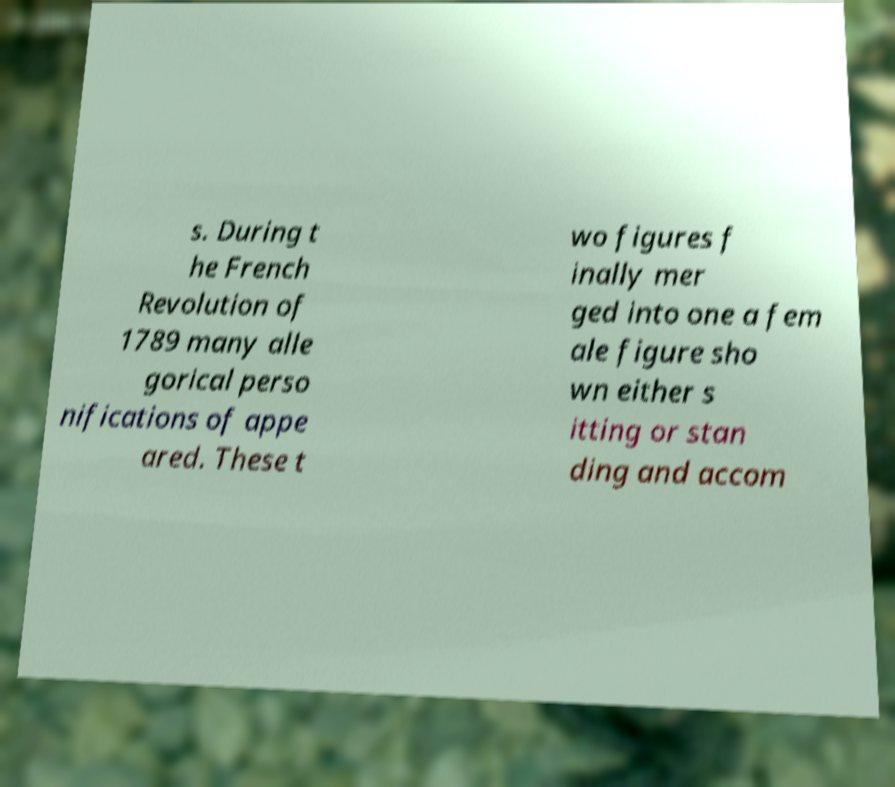Could you extract and type out the text from this image? s. During t he French Revolution of 1789 many alle gorical perso nifications of appe ared. These t wo figures f inally mer ged into one a fem ale figure sho wn either s itting or stan ding and accom 